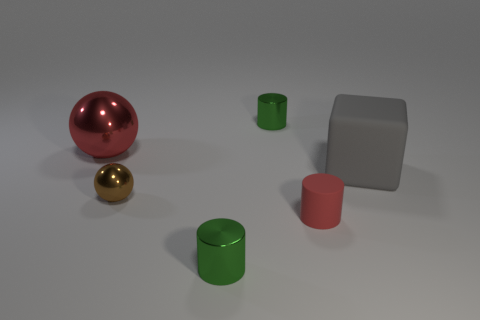How many other objects are the same shape as the gray matte thing?
Your answer should be very brief. 0. There is a green object behind the small shiny cylinder in front of the tiny brown ball; what is its material?
Give a very brief answer. Metal. Is there any other thing that has the same size as the brown metal ball?
Your answer should be very brief. Yes. Is the gray thing made of the same material as the red object that is to the right of the tiny brown sphere?
Keep it short and to the point. Yes. What material is the object that is to the right of the red ball and behind the gray block?
Your response must be concise. Metal. There is a big object to the left of the shiny ball that is in front of the big matte object; what color is it?
Your answer should be very brief. Red. What is the material of the tiny green object that is behind the tiny red thing?
Your response must be concise. Metal. Is the number of small purple matte blocks less than the number of small spheres?
Give a very brief answer. Yes. There is a tiny brown object; is its shape the same as the green thing that is behind the small brown shiny ball?
Ensure brevity in your answer.  No. What is the shape of the metal object that is both behind the tiny brown thing and to the right of the big ball?
Your answer should be compact. Cylinder. 